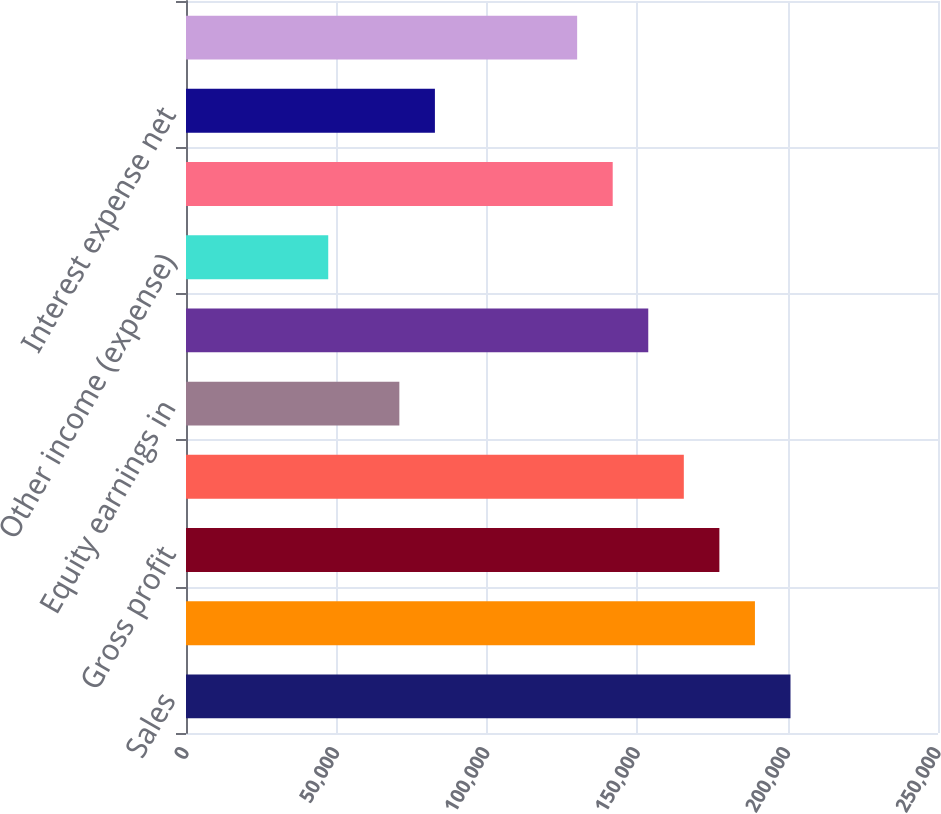Convert chart to OTSL. <chart><loc_0><loc_0><loc_500><loc_500><bar_chart><fcel>Sales<fcel>Cost of sales<fcel>Gross profit<fcel>Selling general and<fcel>Equity earnings in<fcel>Operating income<fcel>Other income (expense)<fcel>Earnings before interest and<fcel>Interest expense net<fcel>Earnings before income tax<nl><fcel>200963<fcel>189142<fcel>177320<fcel>165499<fcel>70929<fcel>153678<fcel>47286.5<fcel>141857<fcel>82750.3<fcel>130035<nl></chart> 